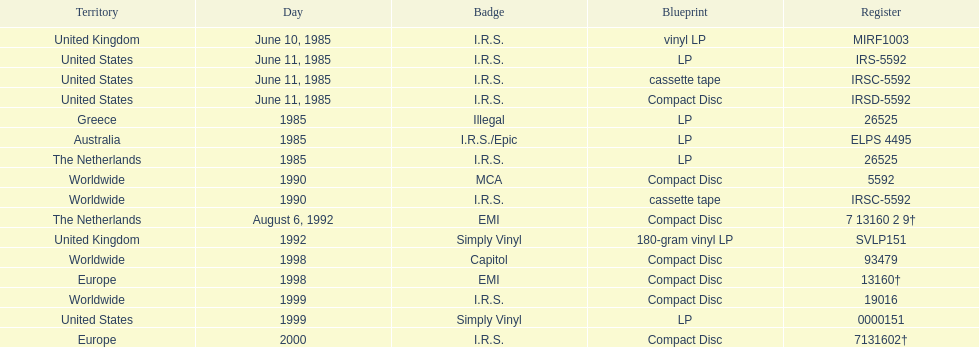Identify a minimum of two labels that published the band's records. I.R.S., Illegal. Parse the full table. {'header': ['Territory', 'Day', 'Badge', 'Blueprint', 'Register'], 'rows': [['United Kingdom', 'June 10, 1985', 'I.R.S.', 'vinyl LP', 'MIRF1003'], ['United States', 'June 11, 1985', 'I.R.S.', 'LP', 'IRS-5592'], ['United States', 'June 11, 1985', 'I.R.S.', 'cassette tape', 'IRSC-5592'], ['United States', 'June 11, 1985', 'I.R.S.', 'Compact Disc', 'IRSD-5592'], ['Greece', '1985', 'Illegal', 'LP', '26525'], ['Australia', '1985', 'I.R.S./Epic', 'LP', 'ELPS 4495'], ['The Netherlands', '1985', 'I.R.S.', 'LP', '26525'], ['Worldwide', '1990', 'MCA', 'Compact Disc', '5592'], ['Worldwide', '1990', 'I.R.S.', 'cassette tape', 'IRSC-5592'], ['The Netherlands', 'August 6, 1992', 'EMI', 'Compact Disc', '7 13160 2 9†'], ['United Kingdom', '1992', 'Simply Vinyl', '180-gram vinyl LP', 'SVLP151'], ['Worldwide', '1998', 'Capitol', 'Compact Disc', '93479'], ['Europe', '1998', 'EMI', 'Compact Disc', '13160†'], ['Worldwide', '1999', 'I.R.S.', 'Compact Disc', '19016'], ['United States', '1999', 'Simply Vinyl', 'LP', '0000151'], ['Europe', '2000', 'I.R.S.', 'Compact Disc', '7131602†']]} 